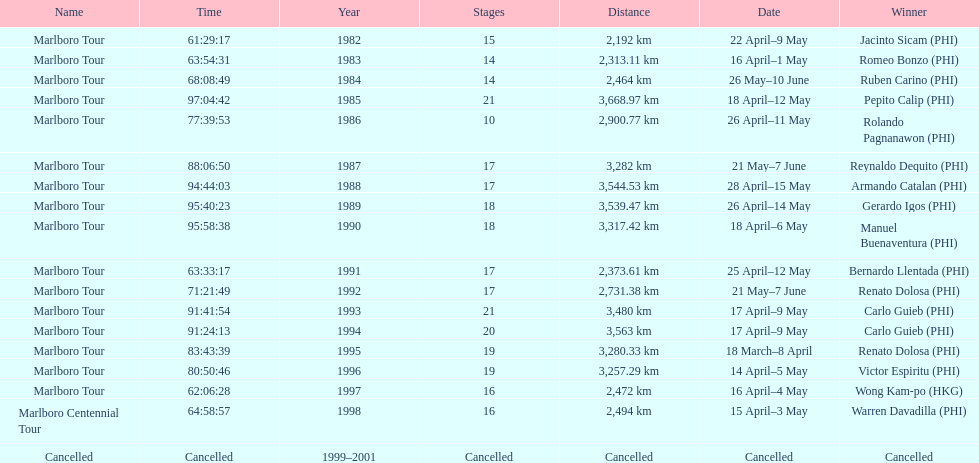What was the total number of winners before the tour was canceled? 17. 